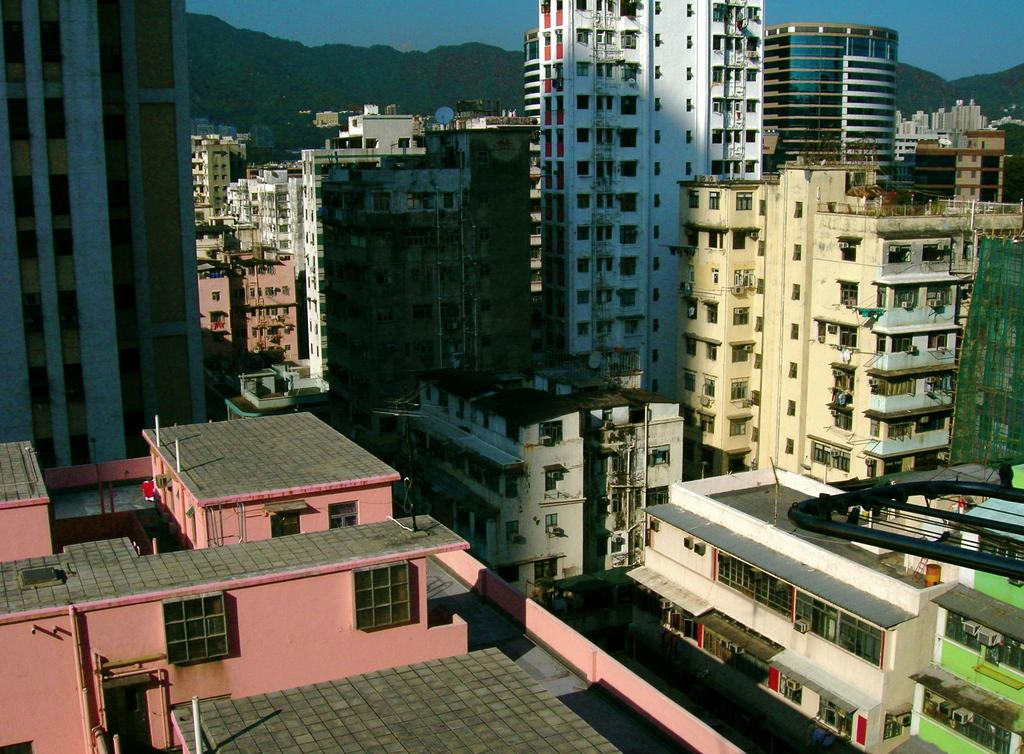What type of structures are present in the image? There are buildings with windows in the image. What feature do the buildings have? The buildings have glass doors. What can be seen in the distance in the image? Hills are visible in the background of the image. What is located at the top of one of the buildings in the image? There is a network dish at the top of a building in the image. Can you see any dolls in the image? No, there are no dolls present in the image. Is there a zoo visible in the background of the image? No, there is no zoo visible in the image; only hills can be seen in the background. 